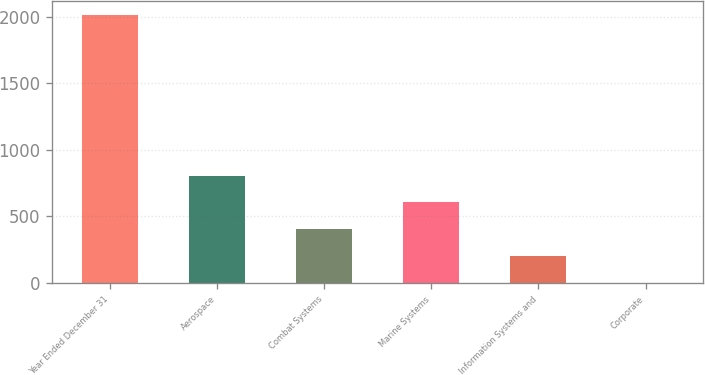Convert chart to OTSL. <chart><loc_0><loc_0><loc_500><loc_500><bar_chart><fcel>Year Ended December 31<fcel>Aerospace<fcel>Combat Systems<fcel>Marine Systems<fcel>Information Systems and<fcel>Corporate<nl><fcel>2013<fcel>805.8<fcel>403.4<fcel>604.6<fcel>202.2<fcel>1<nl></chart> 